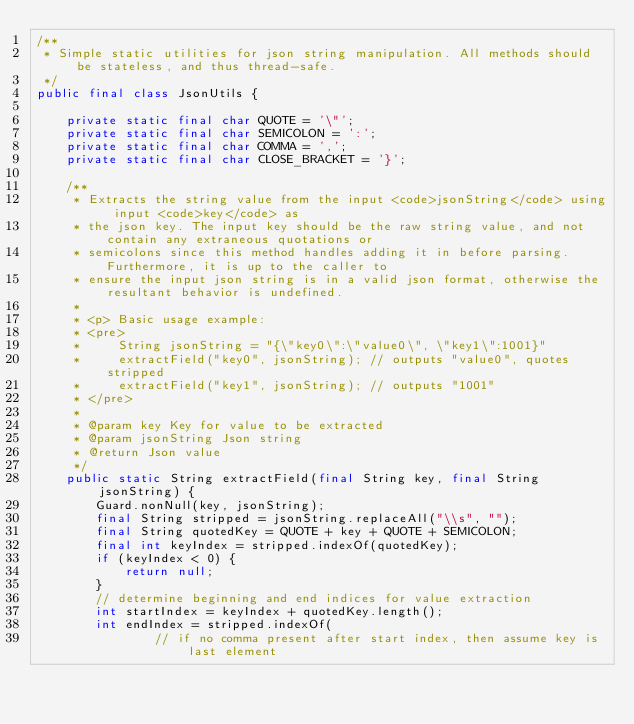<code> <loc_0><loc_0><loc_500><loc_500><_Java_>/**
 * Simple static utilities for json string manipulation. All methods should be stateless, and thus thread-safe.
 */
public final class JsonUtils {

    private static final char QUOTE = '\"';
    private static final char SEMICOLON = ':';
    private static final char COMMA = ',';
    private static final char CLOSE_BRACKET = '}';

    /**
     * Extracts the string value from the input <code>jsonString</code> using input <code>key</code> as
     * the json key. The input key should be the raw string value, and not contain any extraneous quotations or
     * semicolons since this method handles adding it in before parsing. Furthermore, it is up to the caller to
     * ensure the input json string is in a valid json format, otherwise the resultant behavior is undefined.
     *
     * <p> Basic usage example:
     * <pre>
     *     String jsonString = "{\"key0\":\"value0\", \"key1\":1001}"
     *     extractField("key0", jsonString); // outputs "value0", quotes stripped
     *     extractField("key1", jsonString); // outputs "1001"
     * </pre>
     *
     * @param key Key for value to be extracted
     * @param jsonString Json string
     * @return Json value
     */
    public static String extractField(final String key, final String jsonString) {
        Guard.nonNull(key, jsonString);
        final String stripped = jsonString.replaceAll("\\s", "");
        final String quotedKey = QUOTE + key + QUOTE + SEMICOLON;
        final int keyIndex = stripped.indexOf(quotedKey);
        if (keyIndex < 0) {
            return null;
        }
        // determine beginning and end indices for value extraction
        int startIndex = keyIndex + quotedKey.length();
        int endIndex = stripped.indexOf(
                // if no comma present after start index, then assume key is last element</code> 